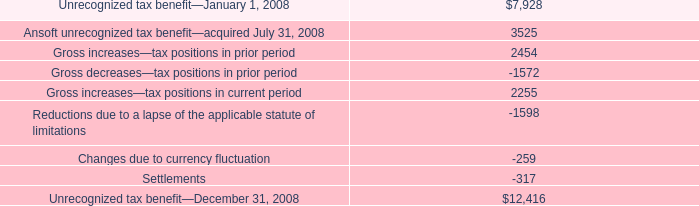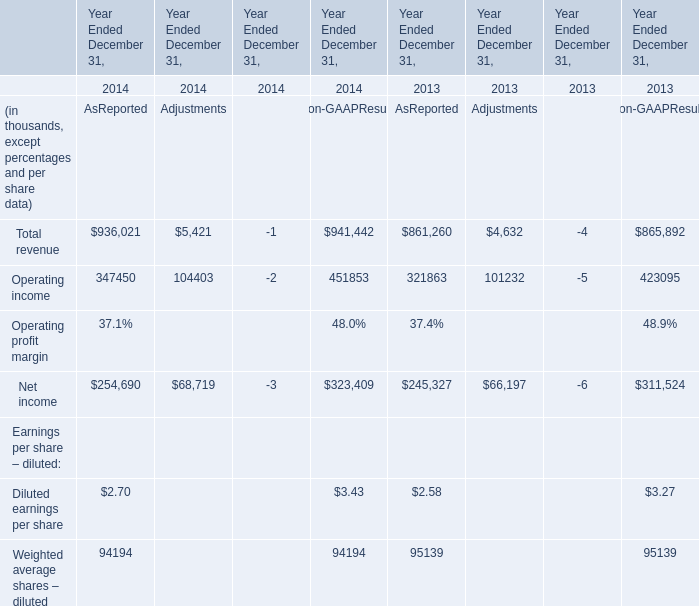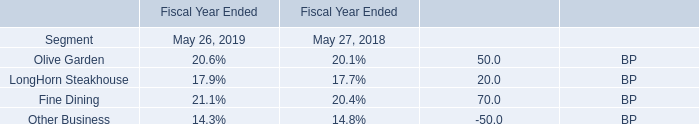What's the average of Operating income of Year Ended December 31, 2013 AsReported, and Gross increases—tax positions in prior period ? 
Computations: ((321863.0 + 2454.0) / 2)
Answer: 162158.5. 